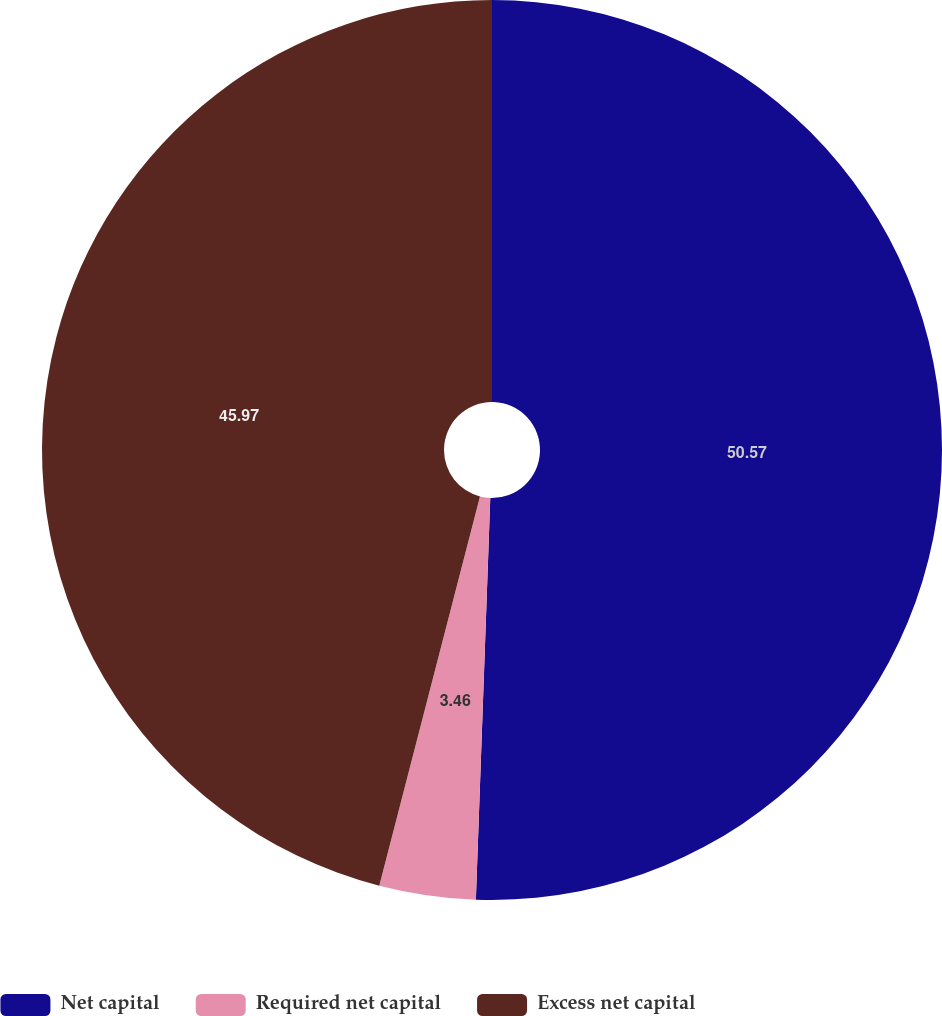<chart> <loc_0><loc_0><loc_500><loc_500><pie_chart><fcel>Net capital<fcel>Required net capital<fcel>Excess net capital<nl><fcel>50.57%<fcel>3.46%<fcel>45.97%<nl></chart> 